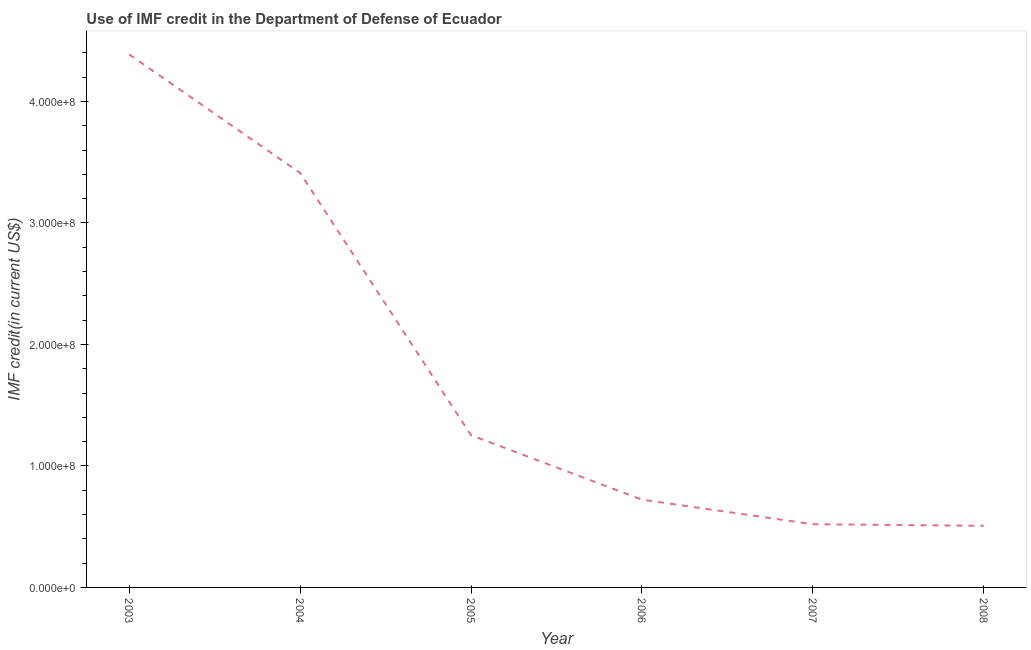What is the use of imf credit in dod in 2005?
Your response must be concise. 1.25e+08. Across all years, what is the maximum use of imf credit in dod?
Your answer should be very brief. 4.39e+08. Across all years, what is the minimum use of imf credit in dod?
Offer a terse response. 5.07e+07. In which year was the use of imf credit in dod maximum?
Keep it short and to the point. 2003. What is the sum of the use of imf credit in dod?
Your response must be concise. 1.08e+09. What is the difference between the use of imf credit in dod in 2003 and 2006?
Offer a very short reply. 3.67e+08. What is the average use of imf credit in dod per year?
Your response must be concise. 1.80e+08. What is the median use of imf credit in dod?
Keep it short and to the point. 9.88e+07. In how many years, is the use of imf credit in dod greater than 60000000 US$?
Your answer should be compact. 4. What is the ratio of the use of imf credit in dod in 2003 to that in 2007?
Offer a very short reply. 8.43. Is the use of imf credit in dod in 2003 less than that in 2008?
Keep it short and to the point. No. Is the difference between the use of imf credit in dod in 2003 and 2007 greater than the difference between any two years?
Keep it short and to the point. No. What is the difference between the highest and the second highest use of imf credit in dod?
Provide a succinct answer. 9.76e+07. What is the difference between the highest and the lowest use of imf credit in dod?
Your answer should be compact. 3.88e+08. In how many years, is the use of imf credit in dod greater than the average use of imf credit in dod taken over all years?
Offer a very short reply. 2. What is the difference between two consecutive major ticks on the Y-axis?
Provide a short and direct response. 1.00e+08. Are the values on the major ticks of Y-axis written in scientific E-notation?
Give a very brief answer. Yes. Does the graph contain any zero values?
Provide a succinct answer. No. What is the title of the graph?
Give a very brief answer. Use of IMF credit in the Department of Defense of Ecuador. What is the label or title of the X-axis?
Offer a very short reply. Year. What is the label or title of the Y-axis?
Provide a short and direct response. IMF credit(in current US$). What is the IMF credit(in current US$) of 2003?
Provide a short and direct response. 4.39e+08. What is the IMF credit(in current US$) in 2004?
Offer a terse response. 3.41e+08. What is the IMF credit(in current US$) of 2005?
Make the answer very short. 1.25e+08. What is the IMF credit(in current US$) in 2006?
Give a very brief answer. 7.23e+07. What is the IMF credit(in current US$) in 2007?
Provide a short and direct response. 5.20e+07. What is the IMF credit(in current US$) of 2008?
Make the answer very short. 5.07e+07. What is the difference between the IMF credit(in current US$) in 2003 and 2004?
Offer a terse response. 9.76e+07. What is the difference between the IMF credit(in current US$) in 2003 and 2005?
Provide a short and direct response. 3.13e+08. What is the difference between the IMF credit(in current US$) in 2003 and 2006?
Provide a succinct answer. 3.67e+08. What is the difference between the IMF credit(in current US$) in 2003 and 2007?
Provide a succinct answer. 3.87e+08. What is the difference between the IMF credit(in current US$) in 2003 and 2008?
Offer a terse response. 3.88e+08. What is the difference between the IMF credit(in current US$) in 2004 and 2005?
Your response must be concise. 2.16e+08. What is the difference between the IMF credit(in current US$) in 2004 and 2006?
Offer a terse response. 2.69e+08. What is the difference between the IMF credit(in current US$) in 2004 and 2007?
Keep it short and to the point. 2.89e+08. What is the difference between the IMF credit(in current US$) in 2004 and 2008?
Give a very brief answer. 2.90e+08. What is the difference between the IMF credit(in current US$) in 2005 and 2006?
Keep it short and to the point. 5.31e+07. What is the difference between the IMF credit(in current US$) in 2005 and 2007?
Your response must be concise. 7.33e+07. What is the difference between the IMF credit(in current US$) in 2005 and 2008?
Your answer should be compact. 7.46e+07. What is the difference between the IMF credit(in current US$) in 2006 and 2007?
Offer a terse response. 2.02e+07. What is the difference between the IMF credit(in current US$) in 2006 and 2008?
Your response must be concise. 2.15e+07. What is the difference between the IMF credit(in current US$) in 2007 and 2008?
Keep it short and to the point. 1.32e+06. What is the ratio of the IMF credit(in current US$) in 2003 to that in 2004?
Ensure brevity in your answer.  1.29. What is the ratio of the IMF credit(in current US$) in 2003 to that in 2005?
Give a very brief answer. 3.5. What is the ratio of the IMF credit(in current US$) in 2003 to that in 2006?
Your answer should be compact. 6.07. What is the ratio of the IMF credit(in current US$) in 2003 to that in 2007?
Your answer should be very brief. 8.43. What is the ratio of the IMF credit(in current US$) in 2003 to that in 2008?
Your answer should be compact. 8.65. What is the ratio of the IMF credit(in current US$) in 2004 to that in 2005?
Provide a short and direct response. 2.72. What is the ratio of the IMF credit(in current US$) in 2004 to that in 2006?
Keep it short and to the point. 4.72. What is the ratio of the IMF credit(in current US$) in 2004 to that in 2007?
Offer a very short reply. 6.56. What is the ratio of the IMF credit(in current US$) in 2004 to that in 2008?
Your response must be concise. 6.73. What is the ratio of the IMF credit(in current US$) in 2005 to that in 2006?
Give a very brief answer. 1.73. What is the ratio of the IMF credit(in current US$) in 2005 to that in 2007?
Provide a short and direct response. 2.41. What is the ratio of the IMF credit(in current US$) in 2005 to that in 2008?
Your answer should be compact. 2.47. What is the ratio of the IMF credit(in current US$) in 2006 to that in 2007?
Your answer should be very brief. 1.39. What is the ratio of the IMF credit(in current US$) in 2006 to that in 2008?
Ensure brevity in your answer.  1.43. 